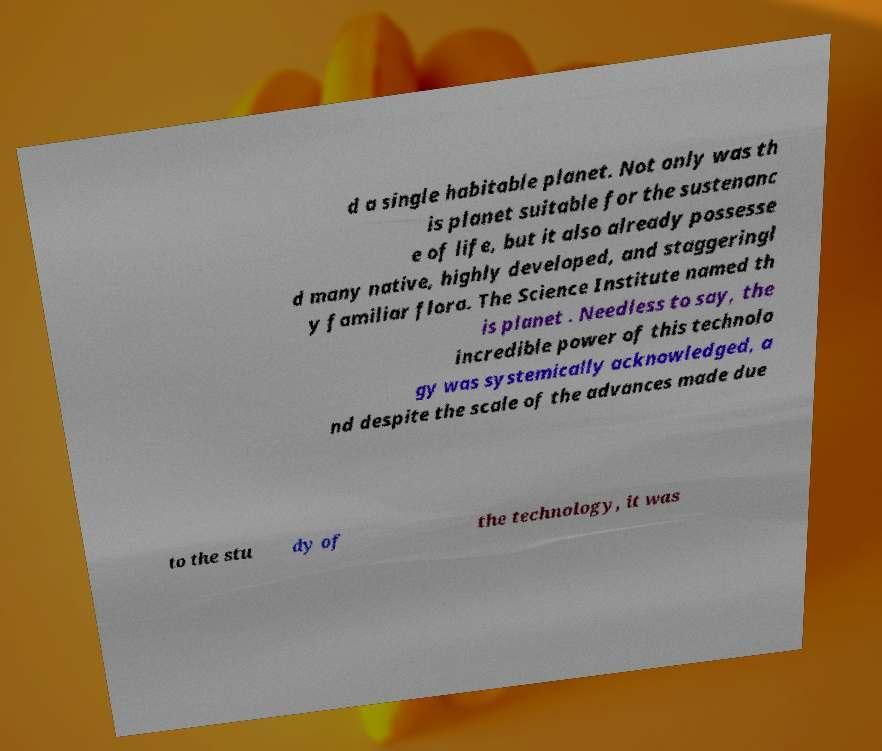What messages or text are displayed in this image? I need them in a readable, typed format. d a single habitable planet. Not only was th is planet suitable for the sustenanc e of life, but it also already possesse d many native, highly developed, and staggeringl y familiar flora. The Science Institute named th is planet . Needless to say, the incredible power of this technolo gy was systemically acknowledged, a nd despite the scale of the advances made due to the stu dy of the technology, it was 